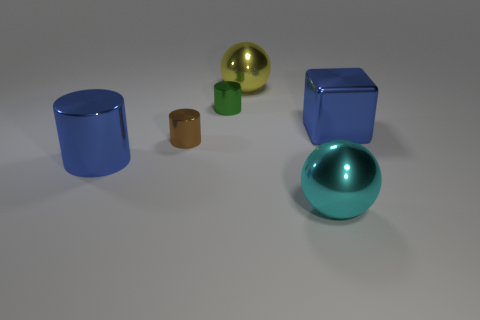Add 1 metal things. How many objects exist? 7 Subtract all balls. How many objects are left? 4 Add 2 small brown cylinders. How many small brown cylinders exist? 3 Subtract 0 red spheres. How many objects are left? 6 Subtract all big blue cylinders. Subtract all large purple matte cylinders. How many objects are left? 5 Add 5 tiny brown cylinders. How many tiny brown cylinders are left? 6 